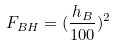Convert formula to latex. <formula><loc_0><loc_0><loc_500><loc_500>F _ { B H } = ( \frac { h _ { B } } { 1 0 0 } ) ^ { 2 }</formula> 